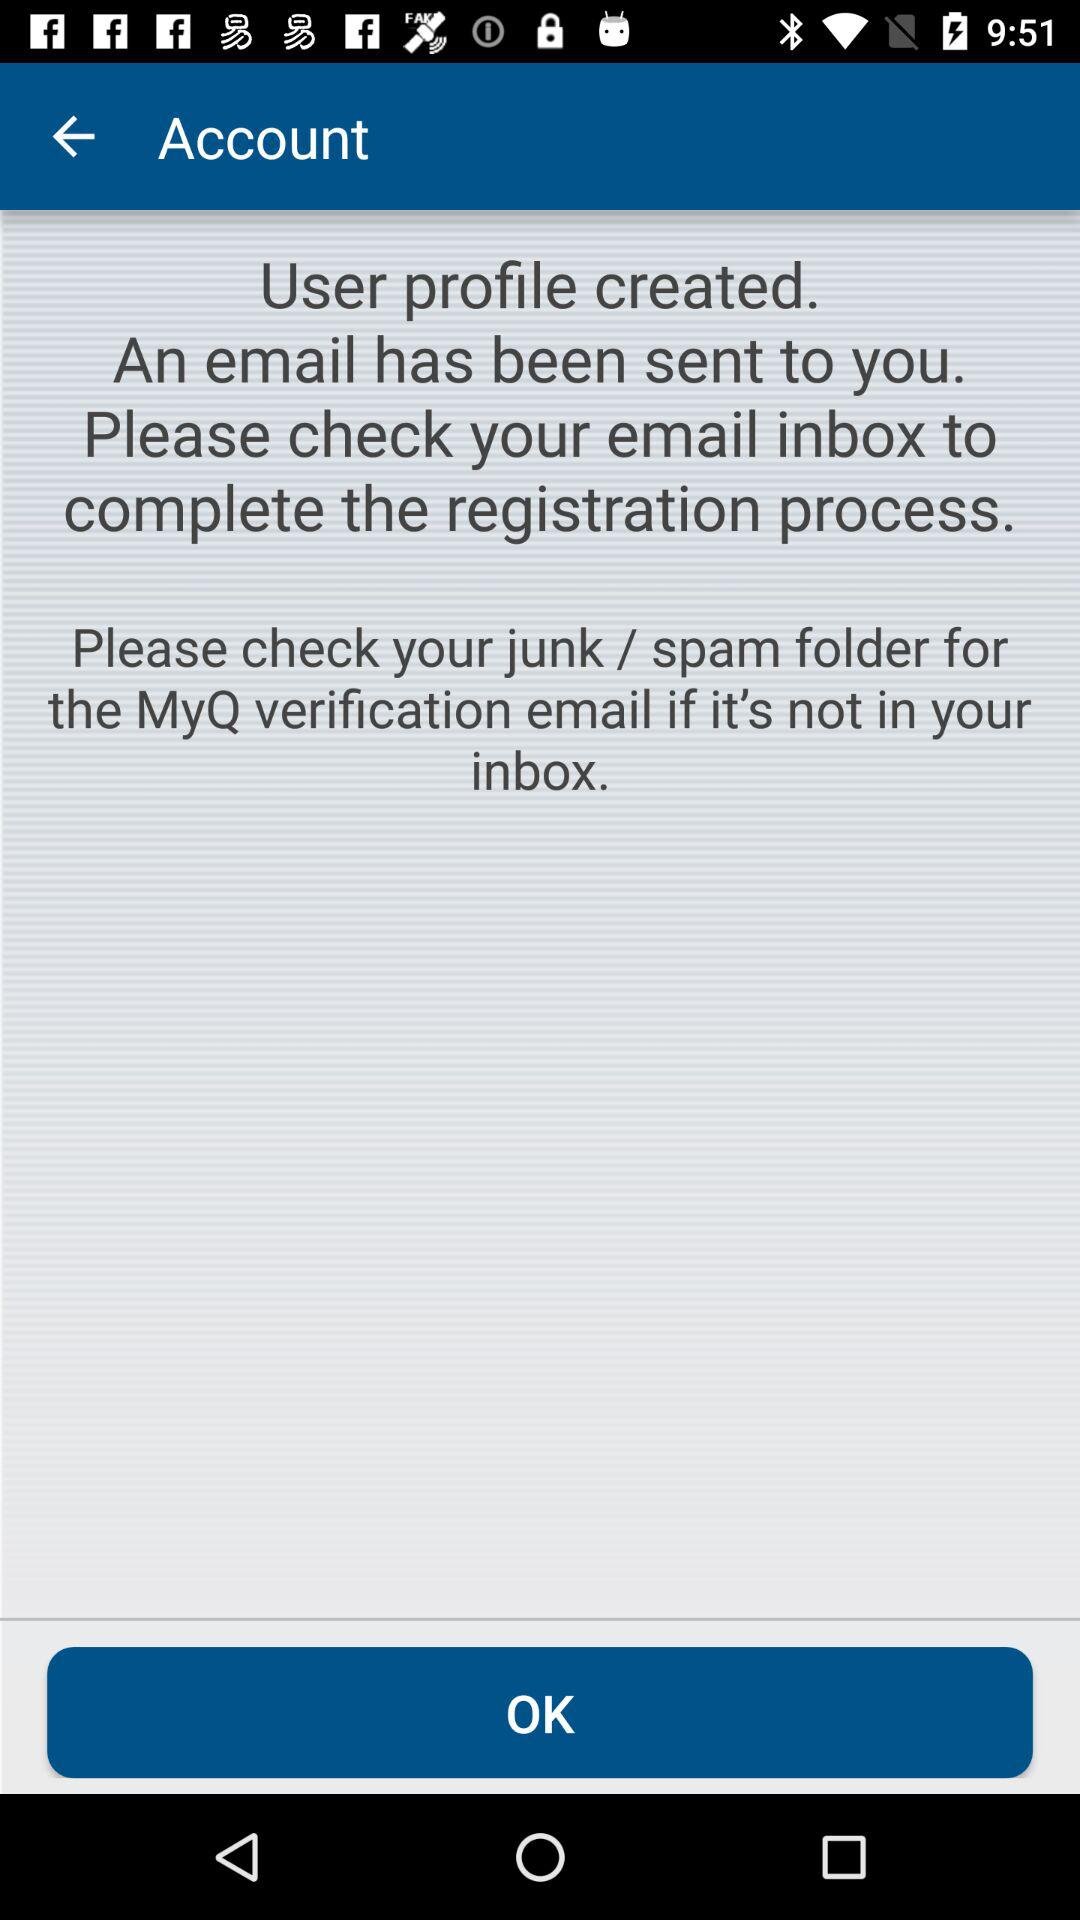What do we have to check to complete the registration process? You have to check your email inbox to complete the registration process. 